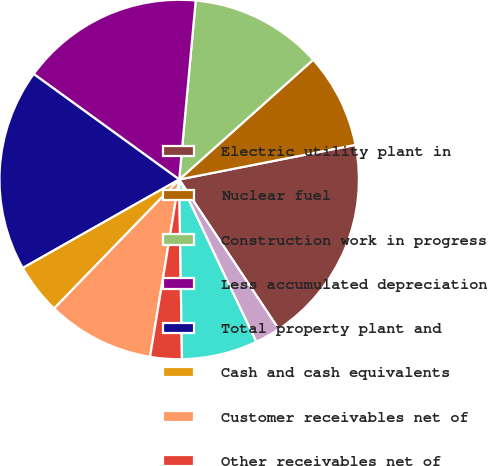Convert chart. <chart><loc_0><loc_0><loc_500><loc_500><pie_chart><fcel>Electric utility plant in<fcel>Nuclear fuel<fcel>Construction work in progress<fcel>Less accumulated depreciation<fcel>Total property plant and<fcel>Cash and cash equivalents<fcel>Customer receivables net of<fcel>Other receivables net of<fcel>Materials supplies and fossil<fcel>Deferred clause and franchise<nl><fcel>18.75%<fcel>8.52%<fcel>11.93%<fcel>16.48%<fcel>18.18%<fcel>4.55%<fcel>9.66%<fcel>2.84%<fcel>6.82%<fcel>2.27%<nl></chart> 